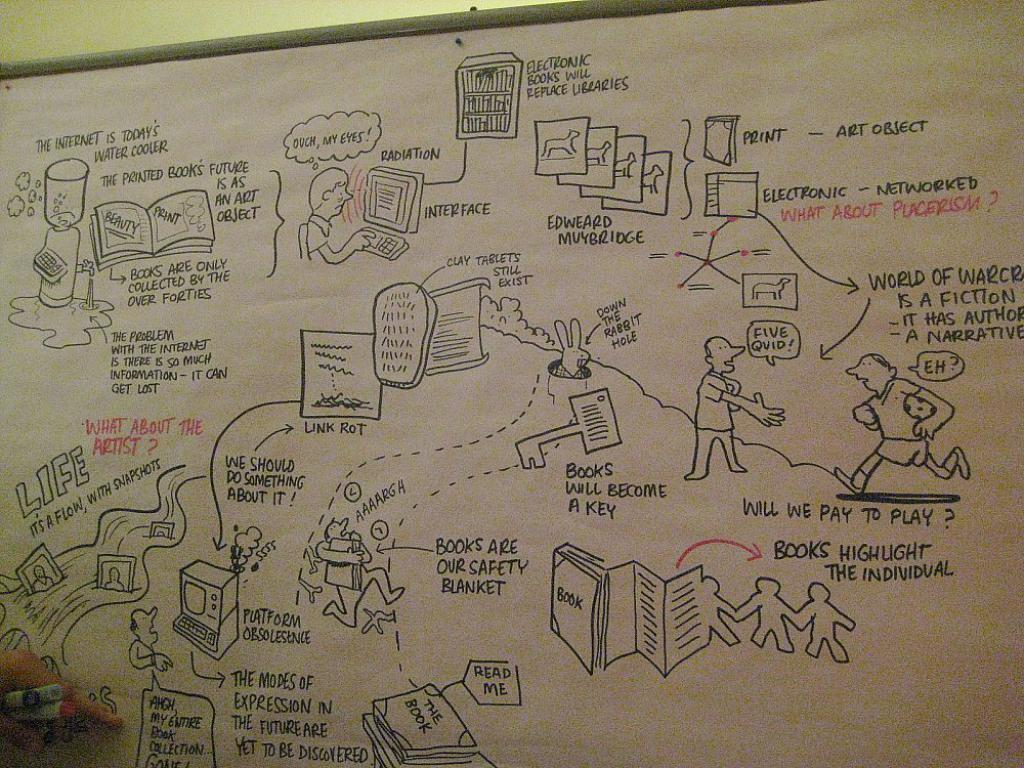Provide a one-sentence caption for the provided image. A cartoonish diagram is on a board and one of the dialog bubbles says "five quid!". 